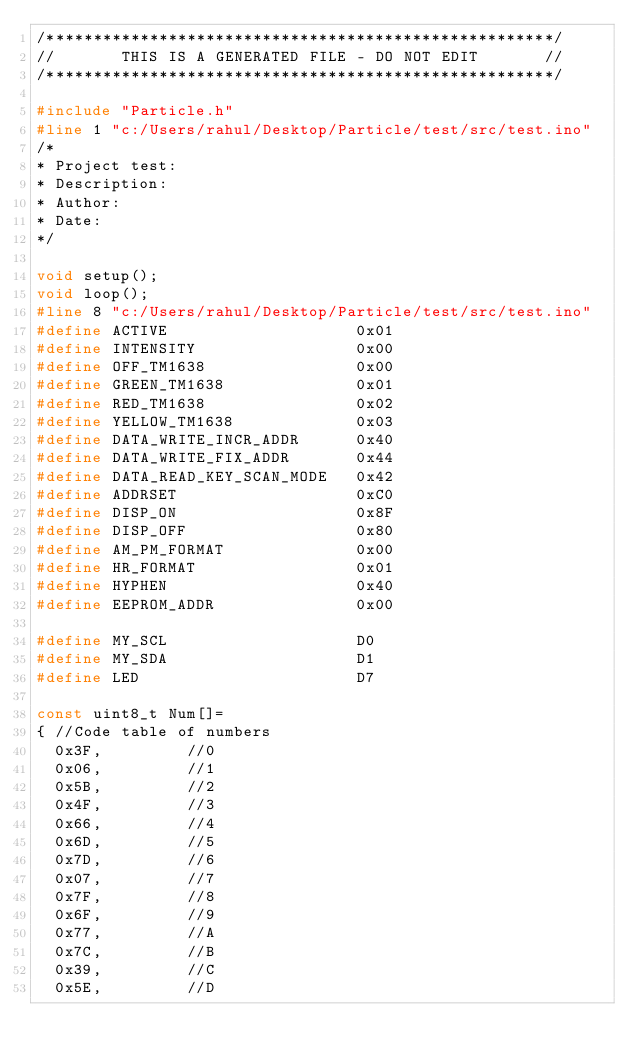Convert code to text. <code><loc_0><loc_0><loc_500><loc_500><_C++_>/******************************************************/
//       THIS IS A GENERATED FILE - DO NOT EDIT       //
/******************************************************/

#include "Particle.h"
#line 1 "c:/Users/rahul/Desktop/Particle/test/src/test.ino"
/*
* Project test: 
* Description:
* Author:
* Date:
*/

void setup();
void loop();
#line 8 "c:/Users/rahul/Desktop/Particle/test/src/test.ino"
#define ACTIVE						        0x01
#define INTENSITY					        0x00
#define OFF_TM1638                0x00
#define GREEN_TM1638 				      0x01
#define RED_TM1638 					      0x02
#define YELLOW_TM1638             0x03
#define DATA_WRITE_INCR_ADDR 		  0x40
#define DATA_WRITE_FIX_ADDR 		  0x44
#define DATA_READ_KEY_SCAN_MODE 	0x42
#define ADDRSET 					        0xC0
#define DISP_ON 					        0x8F
#define DISP_OFF 					        0x80
#define AM_PM_FORMAT              0x00
#define HR_FORMAT                 0x01
#define HYPHEN                    0x40
#define EEPROM_ADDR               0x00

#define MY_SCL                    D0
#define MY_SDA                    D1
#define LED                       D7

const uint8_t Num[]= 
{	//Code table of numbers
	0x3F,					//0
	0x06,					//1
	0x5B,					//2
	0x4F,					//3
	0x66,					//4
	0x6D,					//5
	0x7D,					//6
	0x07,					//7
	0x7F,					//8
	0x6F,					//9
	0x77,					//A
	0x7C,					//B
	0x39,					//C
	0x5E,					//D</code> 